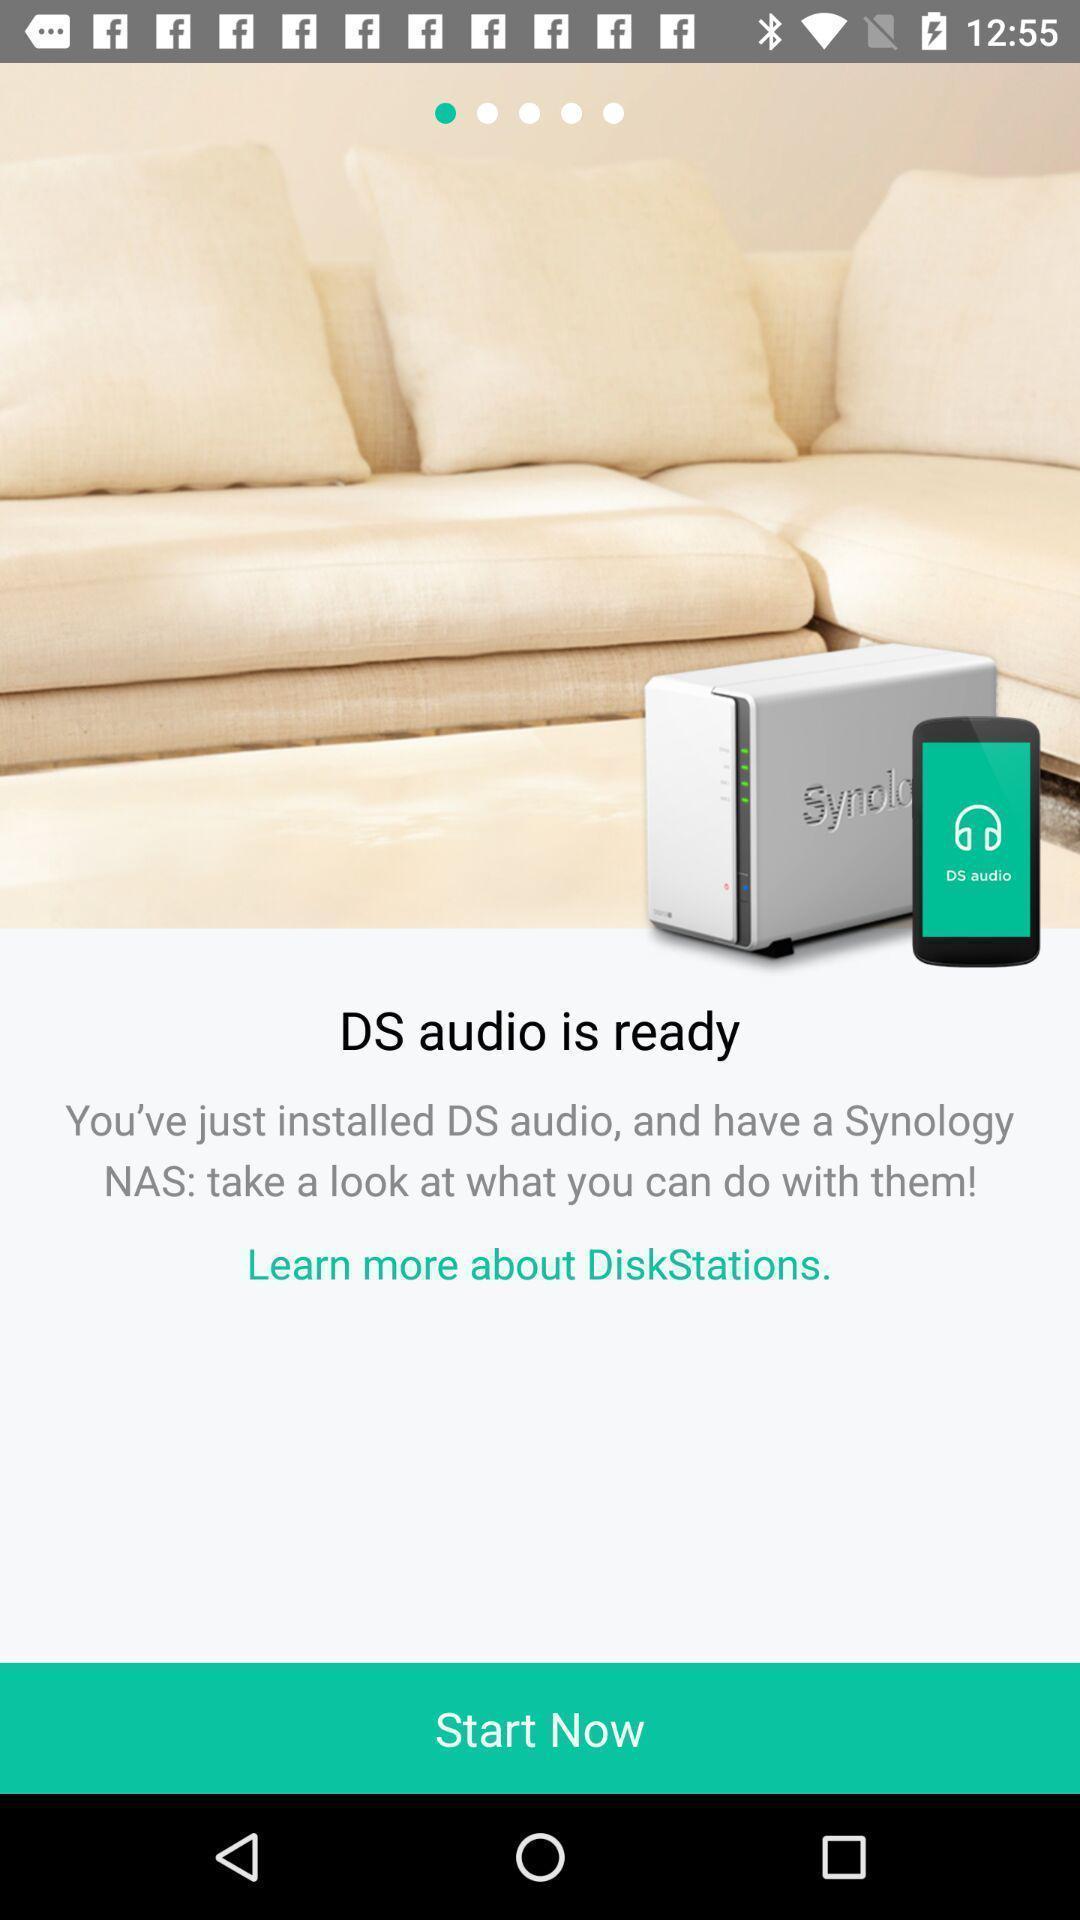Give me a summary of this screen capture. Welcome page for audio player application. 